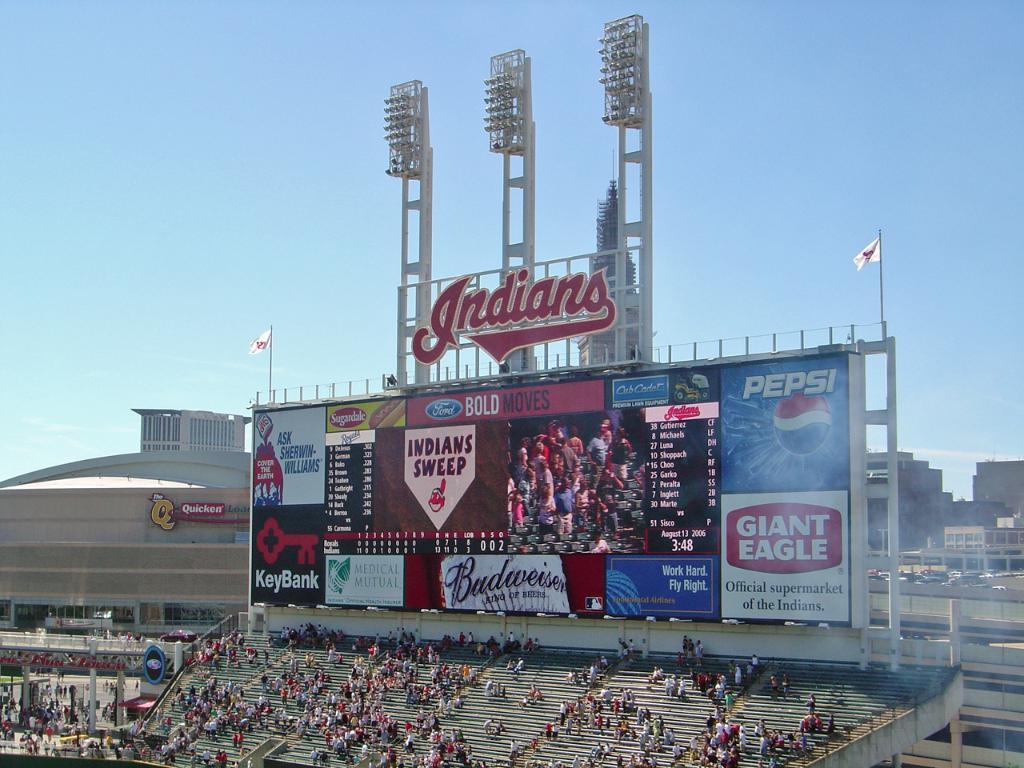Provide a one-sentence caption for the provided image. A large billboard at a stadium displaying the words "Indian Sweep" on the screen. 